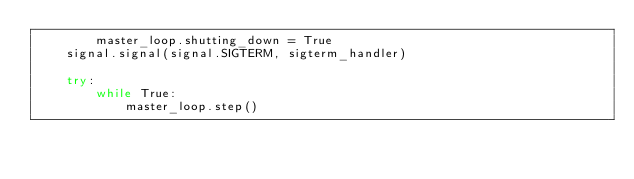<code> <loc_0><loc_0><loc_500><loc_500><_Python_>        master_loop.shutting_down = True
    signal.signal(signal.SIGTERM, sigterm_handler)

    try:
        while True:
            master_loop.step()</code> 